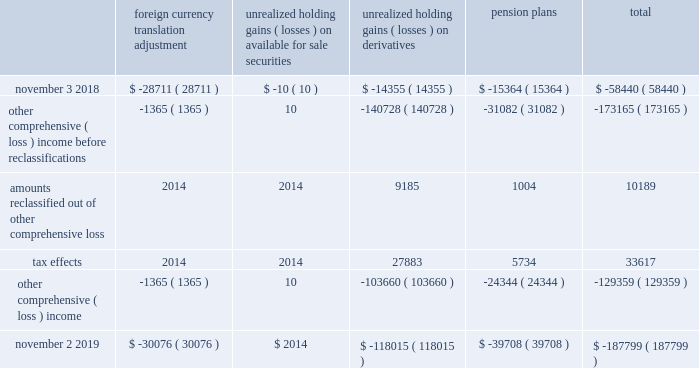Expected durations of less than one year .
The company generally offers a twelve-month warranty for its products .
The company 2019s warranty policy provides for replacement of defective products .
Specific accruals are recorded forff known product warranty issues .
Transaction price : the transaction price reflects the company 2019s expectations about the consideration it will be entitled to receive from the customer and may include fixed or variable amounts .
Fixed consideration primarily includes sales to direct customers and sales to distributors in which both the sale to the distributor and the sale to the end customer occur within the same reporting period .
Variable consideration includes sales in which the amount of consideration that the company will receive is unknown as of the end of a reporting period .
Such consideration primarily includes credits issued to the distributor due to price protection and sales made to distributors under agreements that allow certain rights of return , referred to as stock rotation .
Price protection represents price discounts granted to certain distributors to allow the distributor to earn an appropriate margin on sales negotiated with certain customers and in the event of a price decrease subsequent to the date the product was shipped and billed to the distributor .
Stock rotation allows distributors limited levels of returns in order to reduce the amounts of slow-moving , discontinued or obsolete product from their inventory .
A liability for distributor credits covering variable consideration is made based on the company's estimate of historical experience rates as well as considering economic conditions and contractual terms .
To date , actual distributor claims activity has been materially consistent with the provisions the company has made based on its historical estimates .
For the years ended november 2 , 2019 and november 3 , 2018 , sales to distributors were $ 3.4 billion in both periods , net of variable consideration for which the liability balances as of november 2 , 2019 and november 3 , 2018 were $ 227.0 million and $ 144.9 million , respectively .
Contract balances : accounts receivable represents the company 2019s unconditional right to receive consideration from its customers .
Payments are typically due within 30 to 45 days of invoicing and do not include a significant financing component .
To date , there have been no material impairment losses on accounts receivable .
There were no material contract assets or contract liabilities recorded on the consolidated balance sheets in any of the periods presented .
The company generally warrants that products will meet their published specifications and that the company will repair or replace defective products for twelve-months from the date title passes to the customer .
Specific accruals are recorded for known product warranty issues .
Product warranty expenses during fiscal 2019 , fiscal 2018 and fiscal 2017 were not material .
Accumulated other compcc rehensive ( loss ) income accumulated other comprehensive ( loss ) income ( aoci ) includes certain transactions that have generally been reported in the consolidated statement of shareholders 2019 equity .
The components of aoci at november 2 , 2019 and november 3 , 2018 consisted of the following , net of tax : foreign currency translation adjustment unrealized holding gains ( losses ) on available for sale securities unrealized holding ( losses ) on derivatives pension plans total .
November 2 , 2019 $ ( 30076 ) $ 2014 $ ( 118015 ) $ ( 39708 ) $ ( 187799 ) ( ) ( ) ( ) ( ) ( ) ( ) ( ) ( ) analog devices , inc .
Notes to consolidated financial statements 2014 ( continued ) .
What is the net change in the liability balance from 2018 to 2019? 
Computations: (227.0 - 144.9)
Answer: 82.1. 